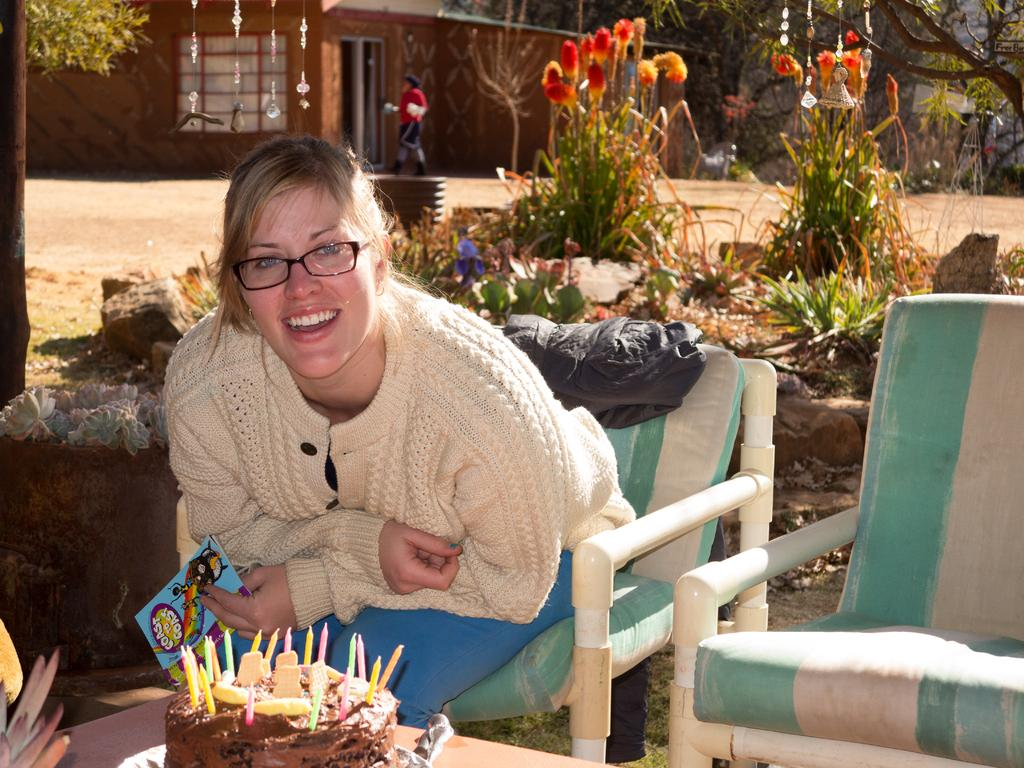What is the person in the image doing? The person is sitting on a chair. What is in front of the person? There is a cake in front of the person. How many candles are on the cake? The cake has many candles on it. What can be seen behind the person? There are plants and a house behind the person. What type of vegetation is visible in the image? There are many trees visible. What type of science experiment is being conducted on the person's finger in the image? There is no science experiment or finger present in the image. 